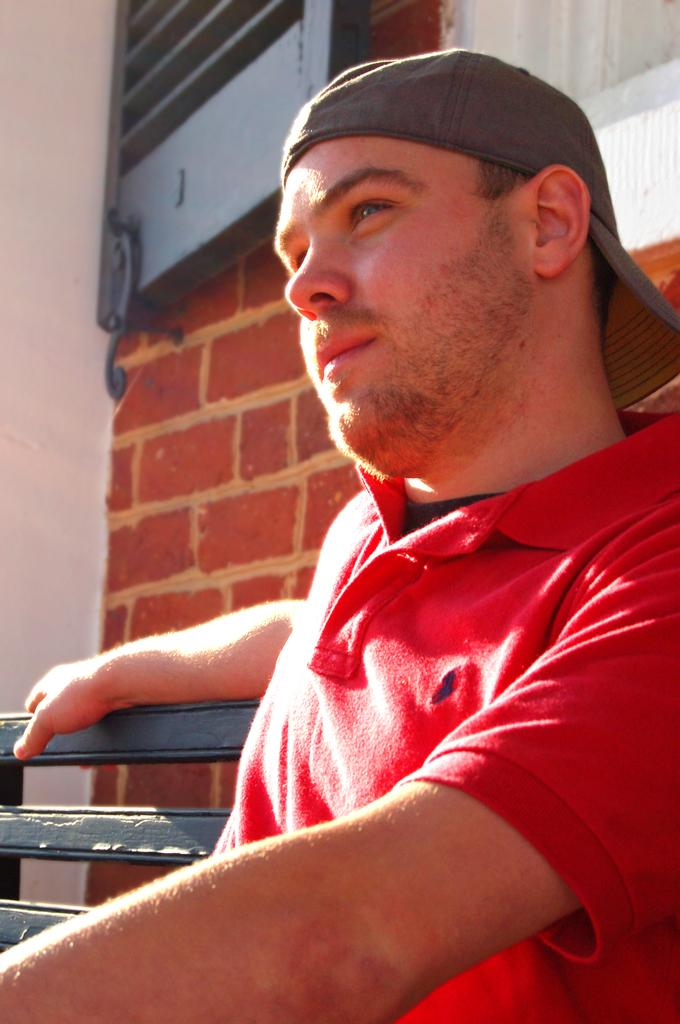Who is the main subject in the image? There is a boy in the image. What is the boy doing in the image? The boy is sitting on a bench. Where is the bench located in the image? The bench is on the right side of the image. What other element can be seen in the image? There is a window in the image. Where is the window located in the image? The window is at the top side of the image. What type of thought can be seen on the canvas in the image? There is no canvas present in the image, and therefore no thoughts can be seen on it. 